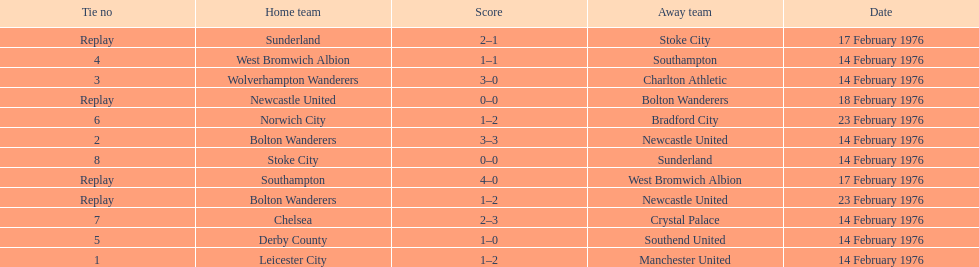Who was the home team in the game on the top of the table? Leicester City. 